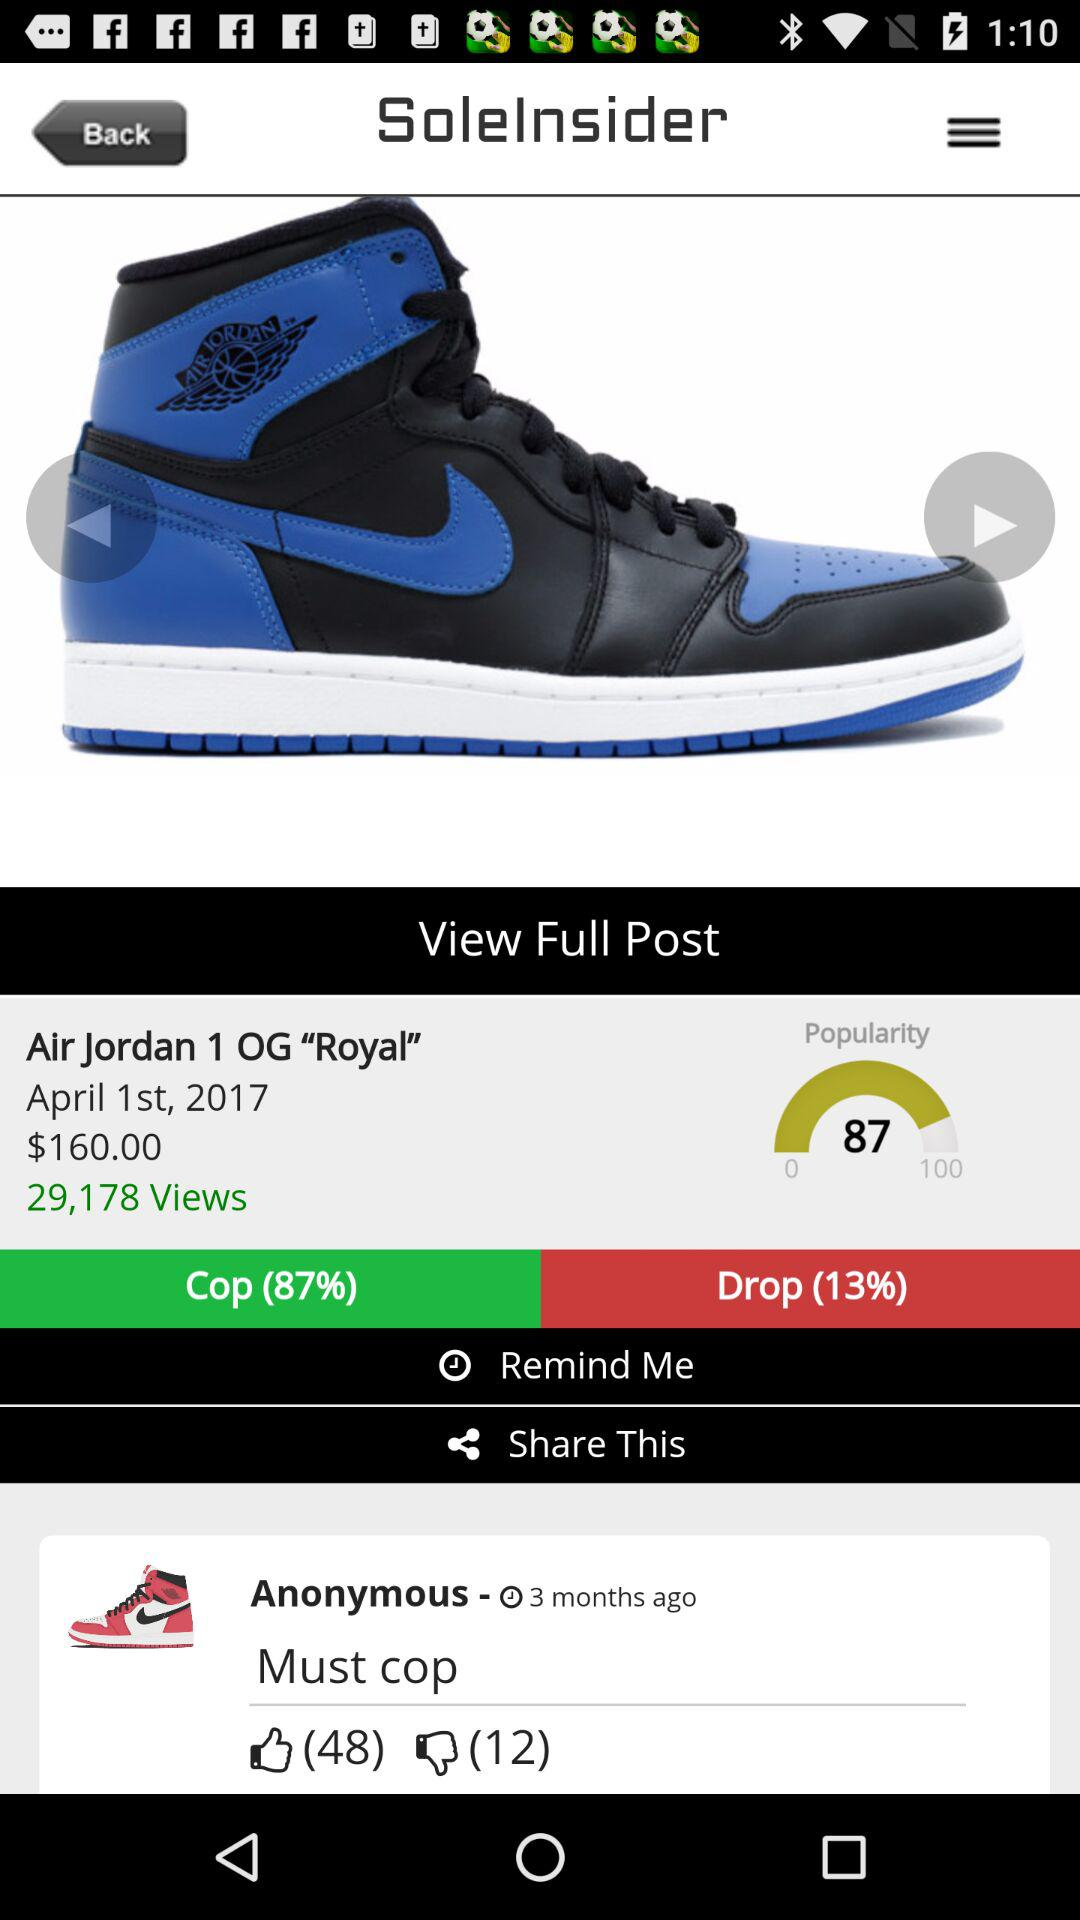What is the cop percentage of "Air Jordan 1 OG "Royal""? The cop percentage of "Air Jordan 1 OG "Royal"" is 87. 